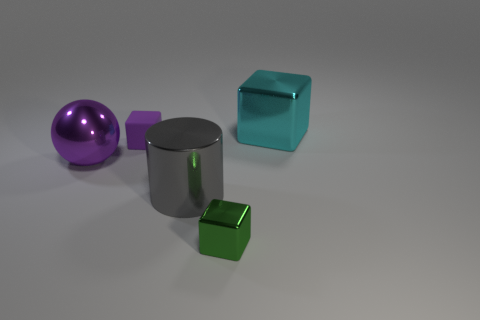What is the material of the purple object that is to the left of the tiny purple block? metal 